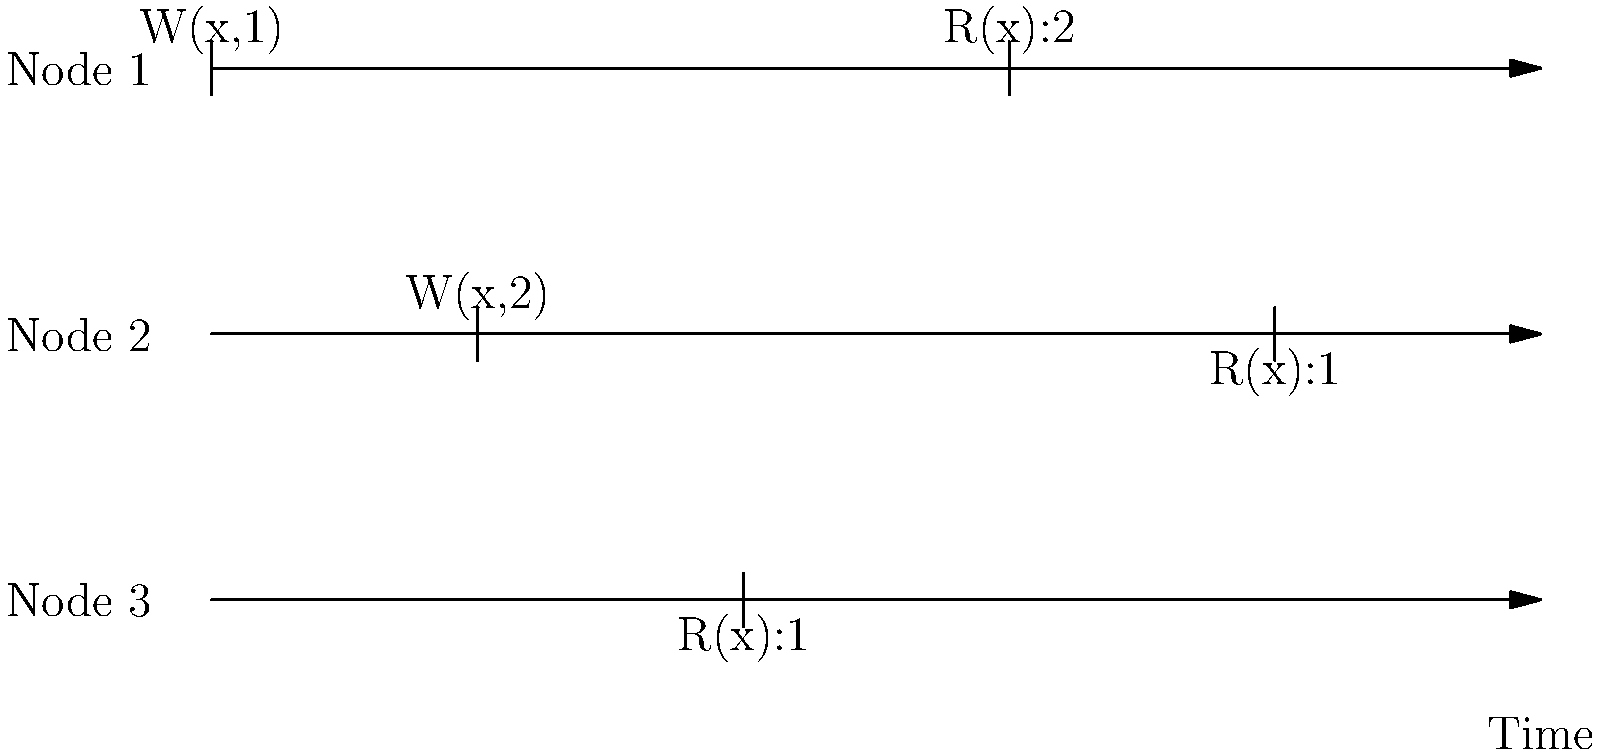In the given timeline diagram of a distributed database system, which consistency model is being violated? Explain your reasoning based on the read and write operations across the three nodes. To determine which consistency model is being violated, let's analyze the sequence of operations:

1. At time t1, Node 1 writes x=1 (W(x,1)).
2. At time t2, Node 2 writes x=2 (W(x,2)).
3. At time t3, Node 3 reads x=1 (R(x):1).
4. At time t4, Node 1 reads x=2 (R(x):2).
5. At time t5, Node 2 reads x=1 (R(x):1).

The violation occurs because:

1. Strong Consistency is violated: In a strongly consistent system, all nodes should see the same value at the same time. Here, different nodes see different values at different times.

2. Causal Consistency is violated: The read at t5 (R(x):1) on Node 2 doesn't reflect the write operation (W(x,2)) that occurred on the same node at t2.

3. Sequential Consistency is violated: There's no single global order of operations that all nodes agree on. Node 3 sees the old value (1) after Node 2 has written the new value (2).

4. Eventual Consistency is maintained: The system might eventually converge to a consistent state, but it's not guaranteed within the given timeline.

The model being violated that best fits this scenario is Sequential Consistency. In a sequentially consistent system, all nodes should observe a consistent global ordering of operations, which is not the case here.
Answer: Sequential Consistency 